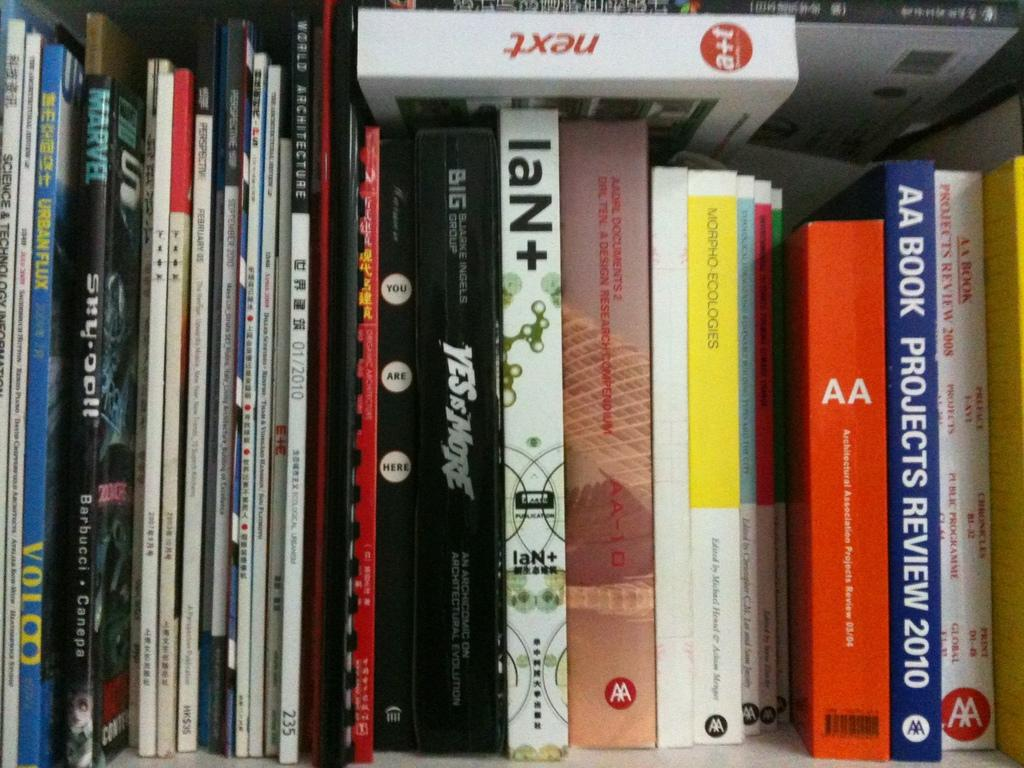<image>
Provide a brief description of the given image. A book titled next is on a shelf on top of other books. 